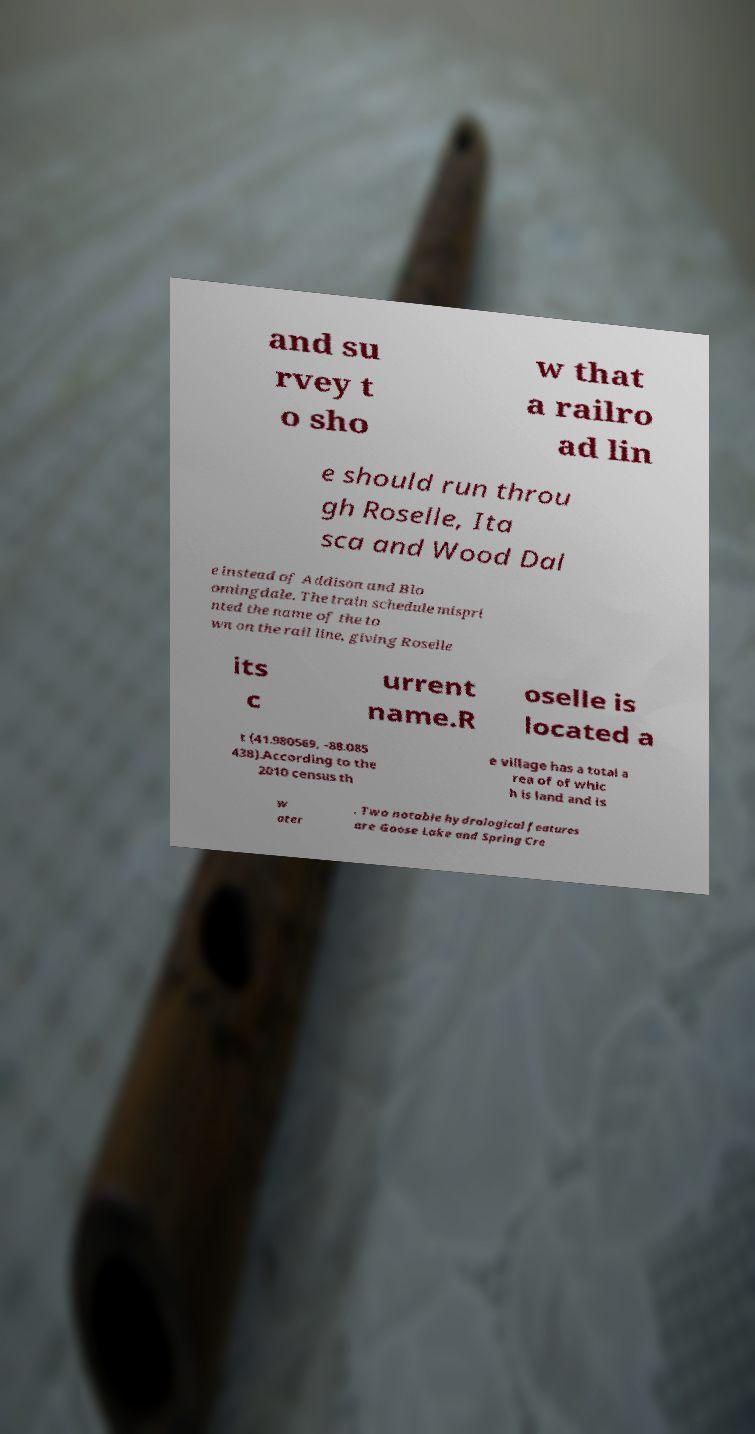Could you assist in decoding the text presented in this image and type it out clearly? and su rvey t o sho w that a railro ad lin e should run throu gh Roselle, Ita sca and Wood Dal e instead of Addison and Blo omingdale. The train schedule mispri nted the name of the to wn on the rail line, giving Roselle its c urrent name.R oselle is located a t (41.980569, -88.085 438).According to the 2010 census th e village has a total a rea of of whic h is land and is w ater . Two notable hydrological features are Goose Lake and Spring Cre 